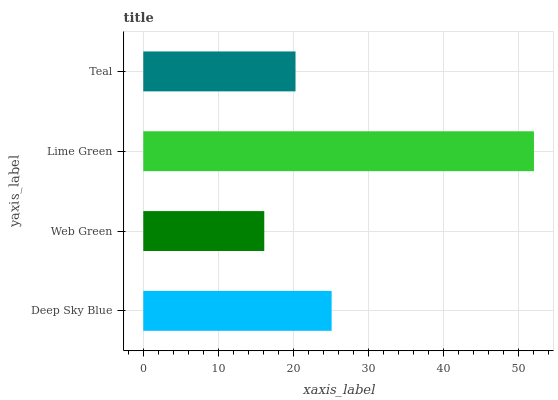Is Web Green the minimum?
Answer yes or no. Yes. Is Lime Green the maximum?
Answer yes or no. Yes. Is Lime Green the minimum?
Answer yes or no. No. Is Web Green the maximum?
Answer yes or no. No. Is Lime Green greater than Web Green?
Answer yes or no. Yes. Is Web Green less than Lime Green?
Answer yes or no. Yes. Is Web Green greater than Lime Green?
Answer yes or no. No. Is Lime Green less than Web Green?
Answer yes or no. No. Is Deep Sky Blue the high median?
Answer yes or no. Yes. Is Teal the low median?
Answer yes or no. Yes. Is Teal the high median?
Answer yes or no. No. Is Lime Green the low median?
Answer yes or no. No. 